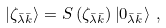Convert formula to latex. <formula><loc_0><loc_0><loc_500><loc_500>\left | \zeta _ { \bar { \lambda } \bar { k } } \right > = S \left ( \zeta _ { \bar { \lambda } \bar { k } } \right ) \left | 0 _ { \bar { \lambda } \bar { k } } \right > \, ,</formula> 